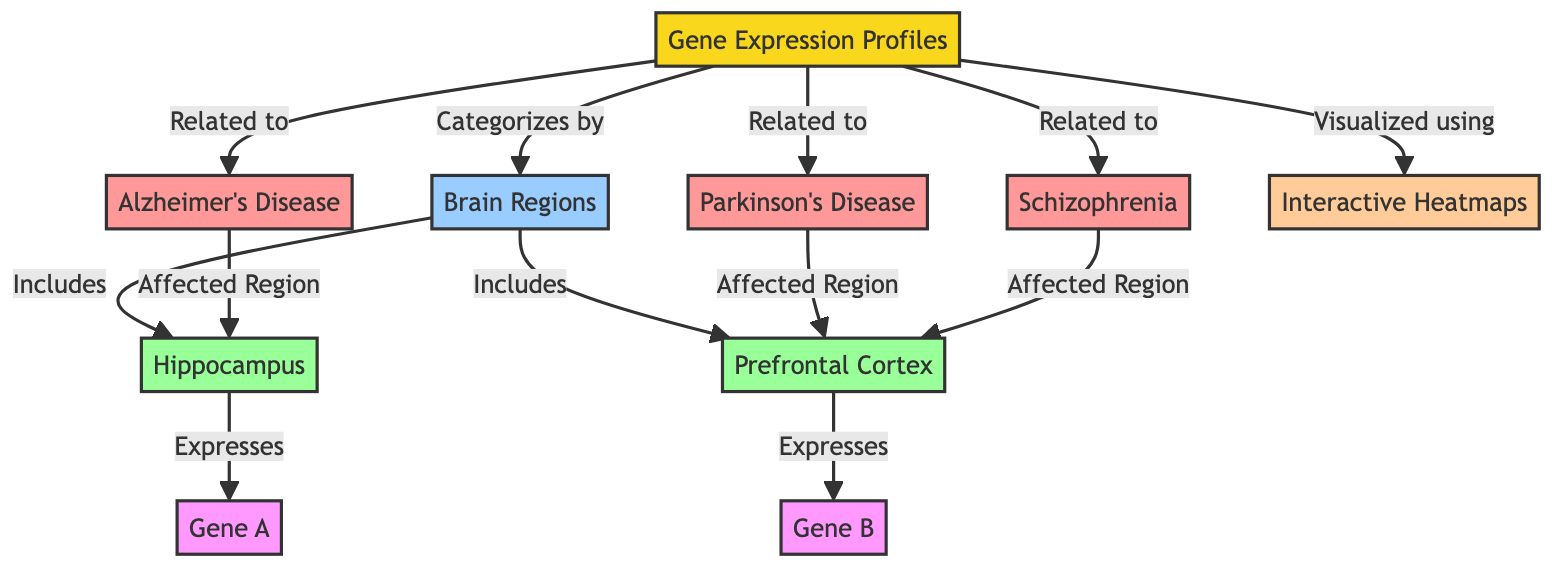What are the three brain disorders mentioned in the diagram? The diagram highlights three brain disorders: Alzheimer's Disease, Parkinson's Disease, and Schizophrenia, all connected to Gene Expression Profiles.
Answer: Alzheimer's Disease, Parkinson's Disease, Schizophrenia Which brain region is associated with Alzheimer's Disease? According to the diagram, the affected region for Alzheimer's Disease is the Hippocampus, as indicated by the flow from the disorder node to this region node.
Answer: Hippocampus How many genes are mentioned in relation to the brain regions? The diagram shows two genes: Gene A is linked to the Hippocampus, and Gene B is connected to the Prefrontal Cortex. Therefore, there are two genes mentioned.
Answer: 2 Which tool is used to visualize the gene expression profiles? The diagram indicates that Interactive Heatmaps are used for visualizing the gene expression profiles, as specified by the connection from the main concept node to the tool node.
Answer: Interactive Heatmaps What brain region expresses Gene B? The diagram states that Gene B is expressed in the Prefrontal Cortex, as shown by the link from the Prefrontal Cortex region to Gene B in the structure of the diagram.
Answer: Prefrontal Cortex Which disorder is linked to the Prefrontal Cortex? According to the diagram, both Parkinson's Disease and Schizophrenia are associated with the Prefrontal Cortex, as shown by the arrows connecting these disorder nodes to the Prefrontal Cortex node.
Answer: Parkinson's Disease, Schizophrenia How many regions are categorized under the brain regions in the diagram? The diagram categorizes two brain regions: the Hippocampus and the Prefrontal Cortex, indicated by the connections under the Brain Regions category.
Answer: 2 Which gene is expressed in the Hippocampus? The diagram specifies that Gene A is expressed in the Hippocampus, illustrated by the link directly from the Hippocampus node to Gene A.
Answer: Gene A What is the main concept of this diagram? The main concept of the diagram is outlined as Gene Expression Profiles, from which other related elements such as disorders and regions are derived.
Answer: Gene Expression Profiles 